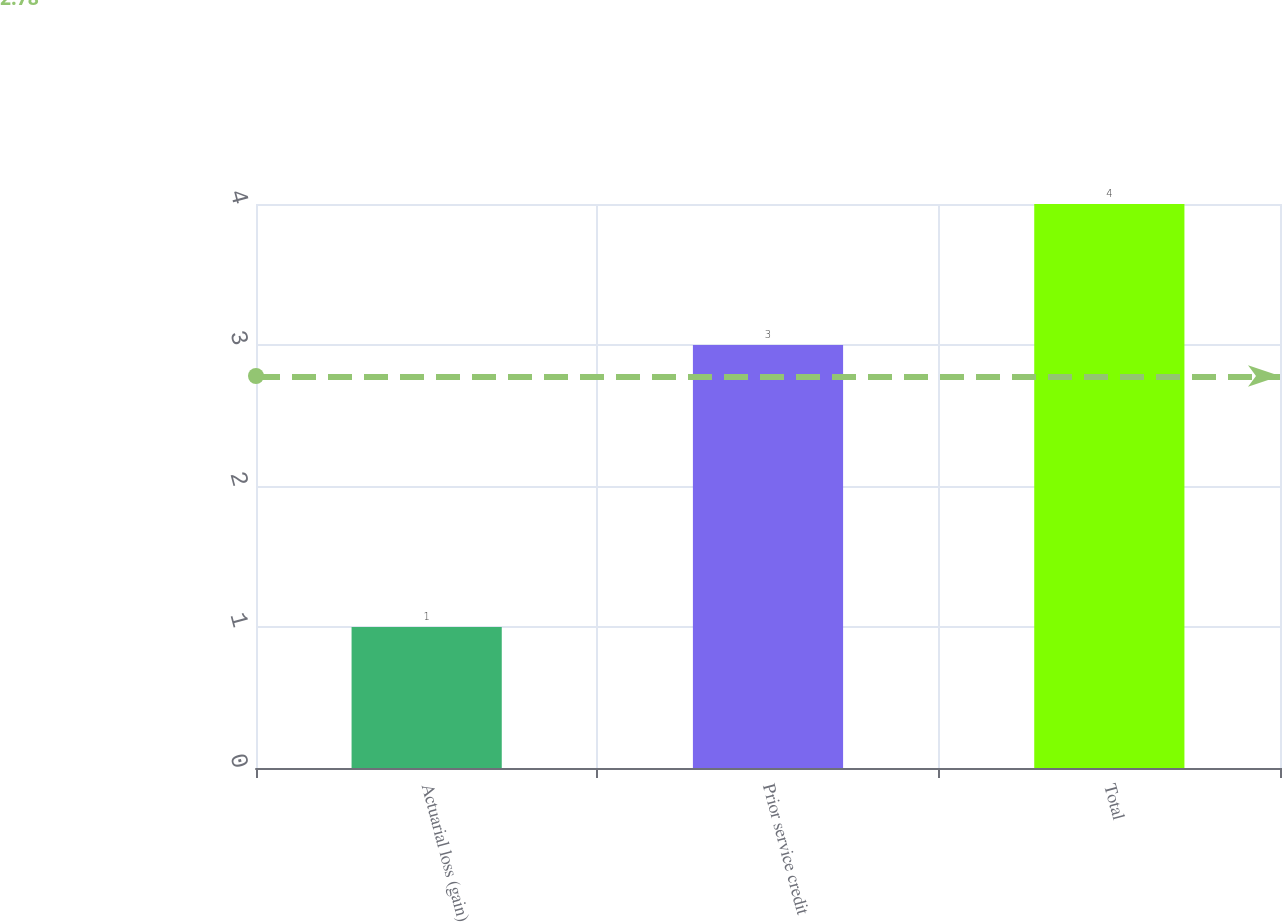<chart> <loc_0><loc_0><loc_500><loc_500><bar_chart><fcel>Actuarial loss (gain)<fcel>Prior service credit<fcel>Total<nl><fcel>1<fcel>3<fcel>4<nl></chart> 